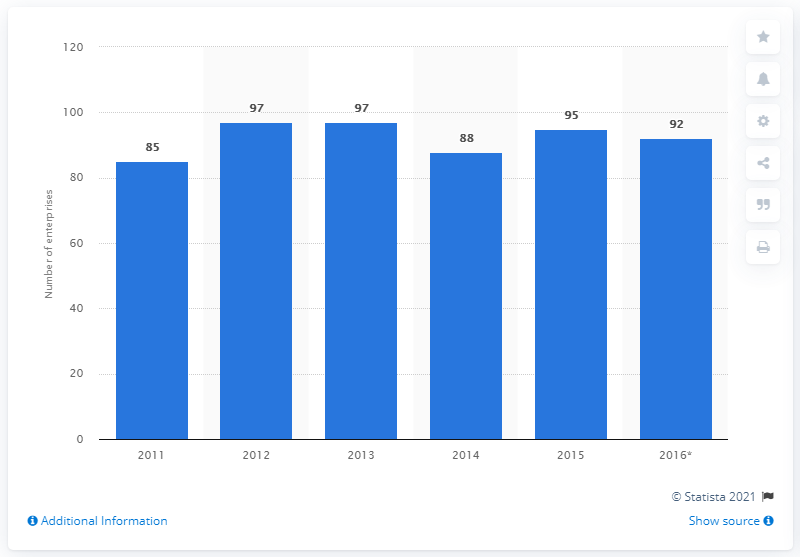Point out several critical features in this image. In 2015, there were 95 enterprises in North Macedonia that manufactured chemicals and chemical products. 